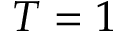Convert formula to latex. <formula><loc_0><loc_0><loc_500><loc_500>T = 1</formula> 